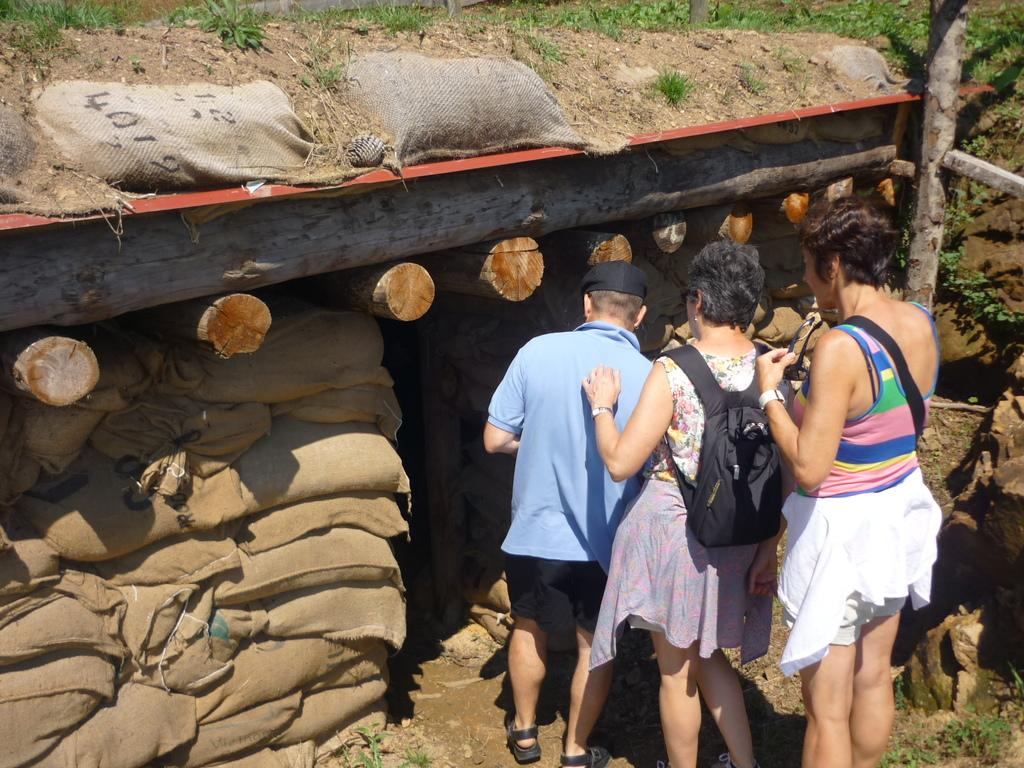How many persons are in the image? There are three persons in the image. What are the persons standing in front of? The persons are standing in front of bags. What other objects are present in the image? Wooden logs are present in the image. What type of produce can be seen growing in the image? There is no produce visible in the image. Is there a sink present in the image? There is no sink present in the image. 